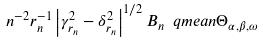<formula> <loc_0><loc_0><loc_500><loc_500>n ^ { - 2 } r _ { n } ^ { - 1 } \left | \gamma _ { r _ { n } } ^ { 2 } - \delta _ { r _ { n } } ^ { 2 } \right | ^ { 1 / 2 } B _ { n } \ q m e a n \Theta _ { \alpha , \beta , \omega }</formula> 